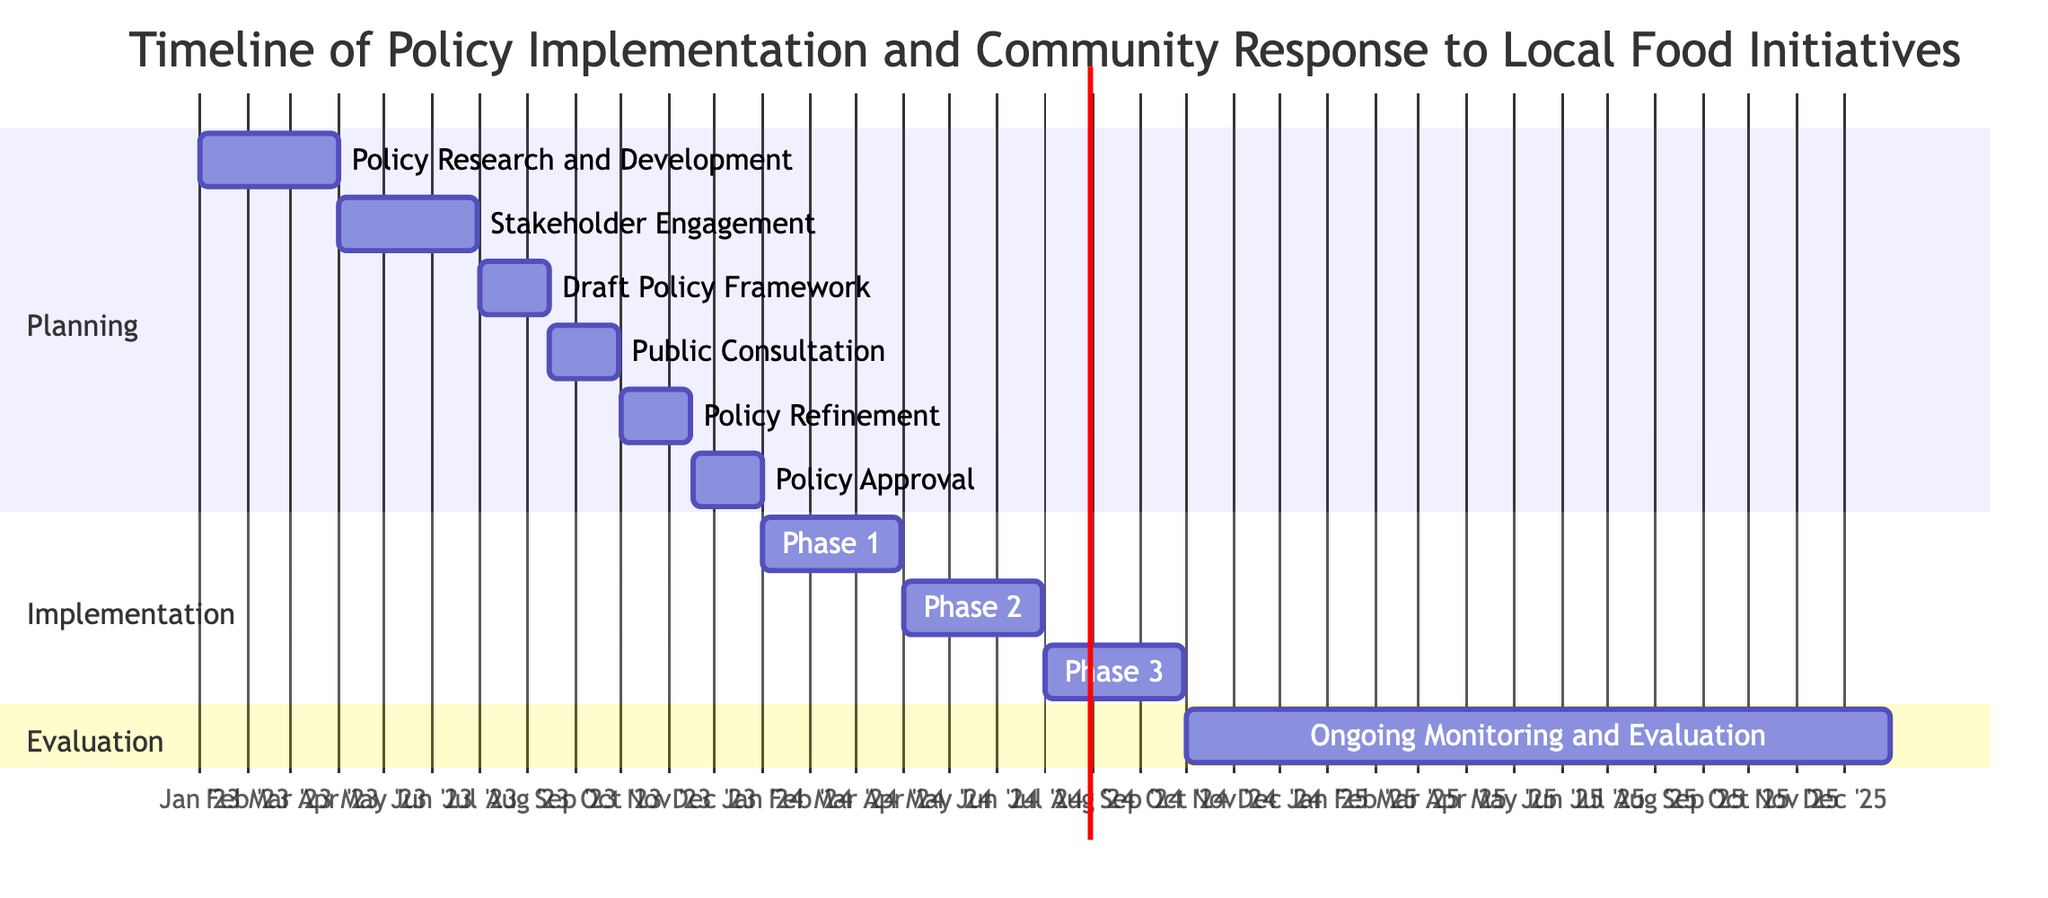What is the duration of the "Policy Research and Development" task? The task "Policy Research and Development" starts on January 1, 2023, and ends on March 31, 2023. To calculate the duration, we find the difference between these two dates, which is 3 months.
Answer: 3 months Which entity is responsible for the "Public Consultation" task? The "Public Consultation" task involves "Community Members" and "Local Businesses". By reviewing this segment, we identify the entities listed within that particular task.
Answer: Community Members, Local Businesses How many phases are included in the implementation stage? In the implementation section, there are three defined phases: Phase 1, Phase 2, and Phase 3. Counting these phases gives us a total of three.
Answer: 3 Which task follows the "Policy Refinement" task? The "Policy Refinement" task ends on November 15, 2023, and the next task, "Policy Approval," begins right after on November 16, 2023. This relationship is determined by checking the end date of the current task and the start date of the next task.
Answer: Policy Approval What is the start date of "Implementation Phase 2: Funding and Grants Allocation"? The "Implementation Phase 2: Funding and Grants Allocation" task starts on April 1, 2024. This information is directly referenced from the task details, indicating its beginning date.
Answer: April 1, 2024 What is the end date for the "Ongoing Monitoring and Evaluation" task? The task "Ongoing Monitoring and Evaluation" is set to end on December 31, 2025. This end date is specified clearly in the diagram for that particular task.
Answer: December 31, 2025 During which dates is "Draft Policy Framework" scheduled? The "Draft Policy Framework" task is scheduled to take place from July 1, 2023, to August 15, 2023. By extracting the start and end dates for this task, we can state the specific timeline.
Answer: July 1, 2023 - August 15, 2023 Which section of the Gantt chart contains "Phase 1: Education and Awareness"? "Phase 1: Education and Awareness" is located in the "Implementation" section of the Gantt chart. This can be verified by looking at the sections divided within the diagram.
Answer: Implementation 